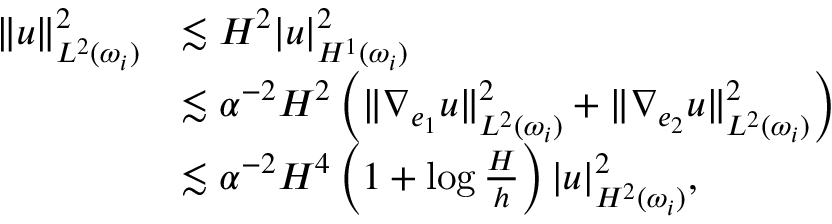<formula> <loc_0><loc_0><loc_500><loc_500>\begin{array} { r l } { \| u \| _ { L ^ { 2 } ( \omega _ { i } ) } ^ { 2 } } & { \lesssim H ^ { 2 } | u | _ { H ^ { 1 } ( \omega _ { i } ) } ^ { 2 } } \\ & { \lesssim \alpha ^ { - 2 } H ^ { 2 } \left ( \| \nabla _ { e _ { 1 } } u \| _ { L ^ { 2 } ( \omega _ { i } ) } ^ { 2 } + \| \nabla _ { e _ { 2 } } u \| _ { L ^ { 2 } ( \omega _ { i } ) } ^ { 2 } \right ) } \\ & { \lesssim \alpha ^ { - 2 } H ^ { 4 } \left ( 1 + \log \frac { H } { h } \right ) | u | _ { H ^ { 2 } ( \omega _ { i } ) } ^ { 2 } , } \end{array}</formula> 